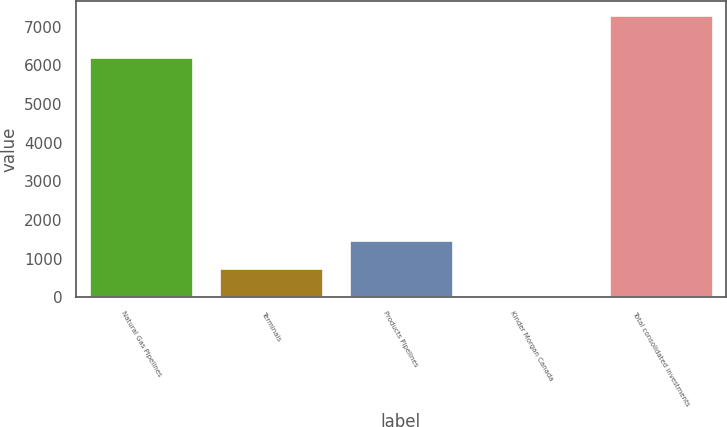Convert chart to OTSL. <chart><loc_0><loc_0><loc_500><loc_500><bar_chart><fcel>Natural Gas Pipelines<fcel>Terminals<fcel>Products Pipelines<fcel>Kinder Morgan Canada<fcel>Total consolidated investments<nl><fcel>6218<fcel>760.4<fcel>1486.8<fcel>34<fcel>7298<nl></chart> 